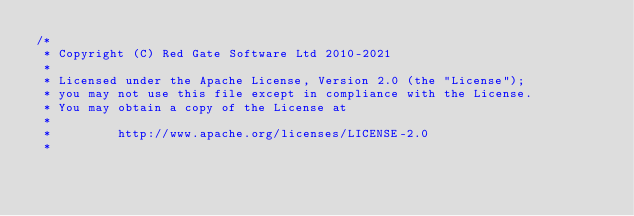<code> <loc_0><loc_0><loc_500><loc_500><_Java_>/*
 * Copyright (C) Red Gate Software Ltd 2010-2021
 *
 * Licensed under the Apache License, Version 2.0 (the "License");
 * you may not use this file except in compliance with the License.
 * You may obtain a copy of the License at
 *
 *         http://www.apache.org/licenses/LICENSE-2.0
 *</code> 